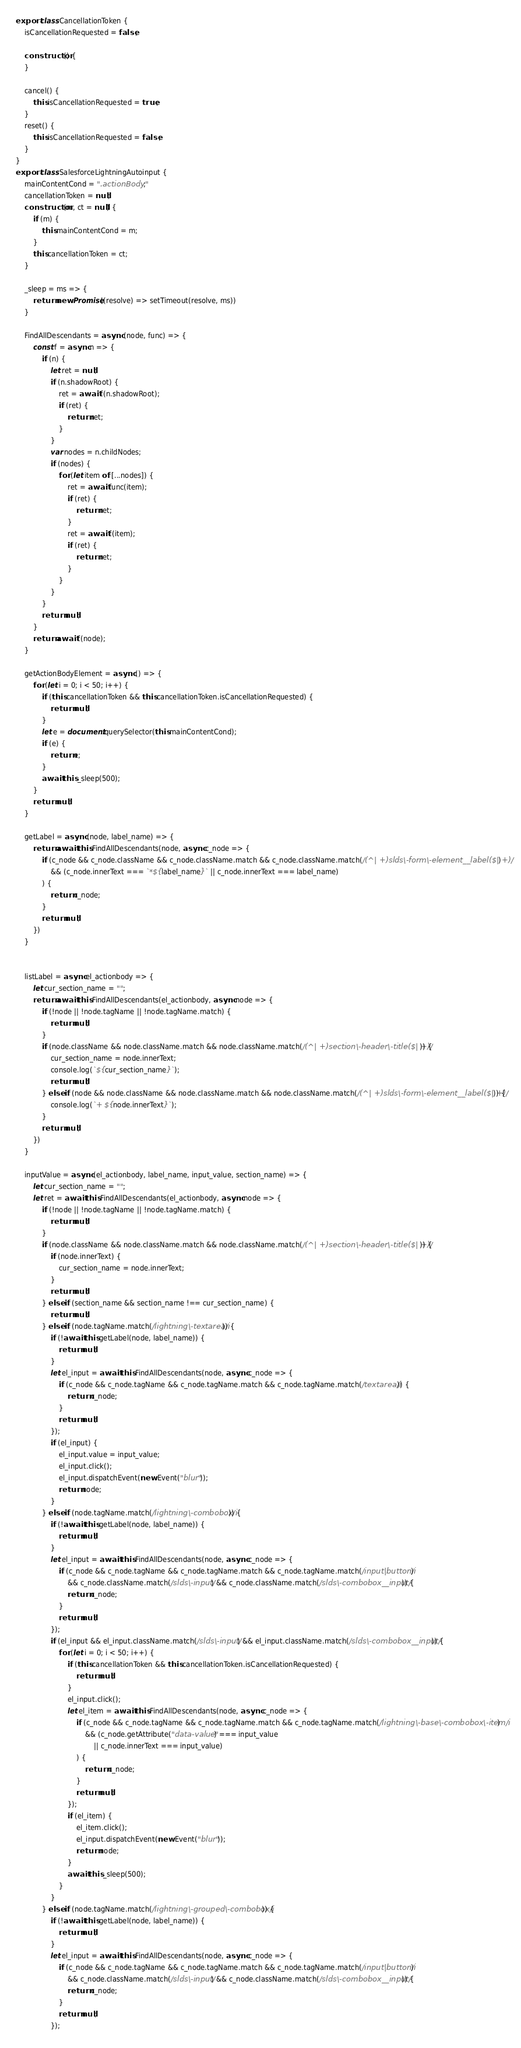Convert code to text. <code><loc_0><loc_0><loc_500><loc_500><_JavaScript_>export class CancellationToken {
	isCancellationRequested = false;

	constructor() {
	}

	cancel() {
		this.isCancellationRequested = true;
	}
	reset() {
		this.isCancellationRequested = false;
    }
}
export class SalesforceLightningAutoinput {
	mainContentCond = ".actionBody";
	cancellationToken = null;
	constructor(m, ct = null) {
		if (m) {
			this.mainContentCond = m;
		}
		this.cancellationToken = ct;
	}

	_sleep = ms => {
		return new Promise((resolve) => setTimeout(resolve, ms))
	}

	FindAllDescendants = async (node, func) => {
		const f = async n => {
			if (n) {
				let ret = null;
				if (n.shadowRoot) {
					ret = await f(n.shadowRoot);
					if (ret) {
						return ret;
					}
				}
				var nodes = n.childNodes;
				if (nodes) {
					for (let item of [...nodes]) {
						ret = await func(item);
						if (ret) {
							return ret;
						}
						ret = await f(item);
						if (ret) {
							return ret;
						}
					}
				}
			}
			return null;
		}
		return await f(node);
	}

	getActionBodyElement = async () => {
		for (let i = 0; i < 50; i++) {
			if (this.cancellationToken && this.cancellationToken.isCancellationRequested) {
				return null;
            }
			let e = document.querySelector(this.mainContentCond);
			if (e) {
				return e;
			}
			await this._sleep(500);
		}
		return null;
	}

	getLabel = async (node, label_name) => {
		return await this.FindAllDescendants(node, async c_node => {
			if (c_node && c_node.className && c_node.className.match && c_node.className.match(/(^| +)slds\-form\-element__label($| +)/)
				&& (c_node.innerText === `*${label_name}` || c_node.innerText === label_name)
			) {
				return c_node;
			}
			return null;
		})
	}


	listLabel = async el_actionbody => {
		let cur_section_name = "";
		return await this.FindAllDescendants(el_actionbody, async node => {
			if (!node || !node.tagName || !node.tagName.match) {
				return null;
			}
			if (node.className && node.className.match && node.className.match(/(^| +)section\-header\-title($| +)/)) {
				cur_section_name = node.innerText;
				console.log(`${cur_section_name}`);
				return null;
			} else if (node && node.className && node.className.match && node.className.match(/(^| +)slds\-form\-element__label($| +)/)) {
				console.log(`+ ${node.innerText}`);
			}
			return null;
		})
	}

	inputValue = async (el_actionbody, label_name, input_value, section_name) => {
		let cur_section_name = "";
		let ret = await this.FindAllDescendants(el_actionbody, async node => {
			if (!node || !node.tagName || !node.tagName.match) {
				return null;
			}
			if (node.className && node.className.match && node.className.match(/(^| +)section\-header\-title($| +)/)) {
				if (node.innerText) {
					cur_section_name = node.innerText;
				}
				return null;
			} else if (section_name && section_name !== cur_section_name) {
				return null;
			} else if (node.tagName.match(/lightning\-textarea/i)) {
				if (!await this.getLabel(node, label_name)) {
					return null;
				}
				let el_input = await this.FindAllDescendants(node, async c_node => {
					if (c_node && c_node.tagName && c_node.tagName.match && c_node.tagName.match(/textarea/i)) {
						return c_node;
					}
					return null;
				});
				if (el_input) {
					el_input.value = input_value;
					el_input.click();
					el_input.dispatchEvent(new Event("blur"));
					return node;
				}
			} else if (node.tagName.match(/lightning\-combobox/i)) {
				if (!await this.getLabel(node, label_name)) {
					return null;
				}
				let el_input = await this.FindAllDescendants(node, async c_node => {
					if (c_node && c_node.tagName && c_node.tagName.match && c_node.tagName.match(/input|button/i)
						&& c_node.className.match(/slds\-input/) && c_node.className.match(/slds\-combobox__input/)) {
						return c_node;
					}
					return null;
				});
				if (el_input && el_input.className.match(/slds\-input/) && el_input.className.match(/slds\-combobox__input/)) {
					for (let i = 0; i < 50; i++) {
						if (this.cancellationToken && this.cancellationToken.isCancellationRequested) {
							return null;
						}
						el_input.click();
						let el_item = await this.FindAllDescendants(node, async c_node => {
							if (c_node && c_node.tagName && c_node.tagName.match && c_node.tagName.match(/lightning\-base\-combobox\-item/i)
								&& (c_node.getAttribute("data-value") === input_value
									|| c_node.innerText === input_value)
							) {
								return c_node;
							}
							return null;
						});
						if (el_item) {
							el_item.click();
							el_input.dispatchEvent(new Event("blur"));
							return node;
						}
						await this._sleep(500);
					}
				}
			} else if (node.tagName.match(/lightning\-grouped\-combobox/i)) {
				if (!await this.getLabel(node, label_name)) {
					return null;
				}
				let el_input = await this.FindAllDescendants(node, async c_node => {
					if (c_node && c_node.tagName && c_node.tagName.match && c_node.tagName.match(/input|button/i)
						&& c_node.className.match(/slds\-input/) && c_node.className.match(/slds\-combobox__input/)) {
						return c_node;
					}
					return null;
				});</code> 